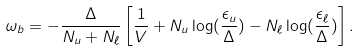Convert formula to latex. <formula><loc_0><loc_0><loc_500><loc_500>\omega _ { b } = - \frac { \Delta } { N _ { u } + N _ { \ell } } \left [ \frac { 1 } { V } + N _ { u } \log ( \frac { \epsilon _ { u } } { \Delta } ) - N _ { \ell } \log ( \frac { \epsilon _ { \ell } } { \Delta } ) \right ] .</formula> 